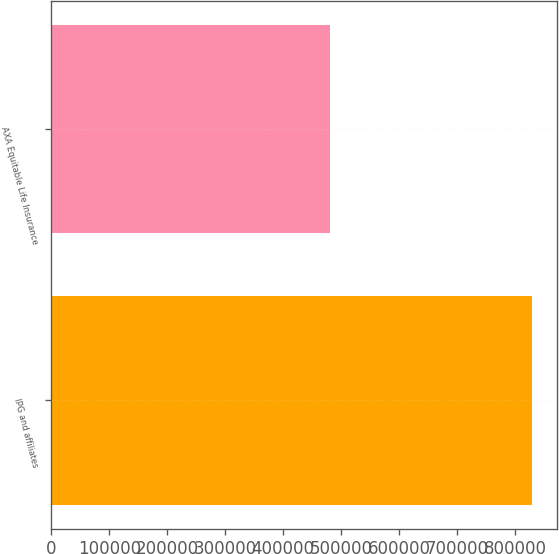Convert chart to OTSL. <chart><loc_0><loc_0><loc_500><loc_500><bar_chart><fcel>IPG and affiliates<fcel>AXA Equitable Life Insurance<nl><fcel>830000<fcel>481000<nl></chart> 